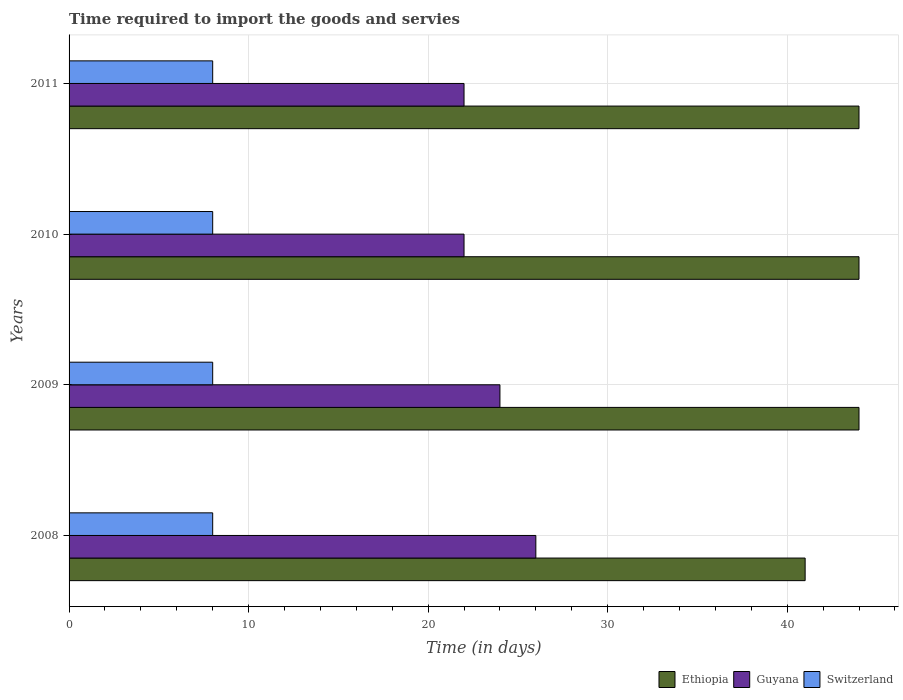Are the number of bars on each tick of the Y-axis equal?
Provide a short and direct response. Yes. How many bars are there on the 4th tick from the top?
Keep it short and to the point. 3. How many bars are there on the 4th tick from the bottom?
Offer a very short reply. 3. What is the label of the 4th group of bars from the top?
Your response must be concise. 2008. In how many cases, is the number of bars for a given year not equal to the number of legend labels?
Offer a terse response. 0. What is the number of days required to import the goods and services in Switzerland in 2011?
Offer a very short reply. 8. Across all years, what is the maximum number of days required to import the goods and services in Guyana?
Provide a succinct answer. 26. Across all years, what is the minimum number of days required to import the goods and services in Switzerland?
Offer a very short reply. 8. In which year was the number of days required to import the goods and services in Ethiopia maximum?
Provide a succinct answer. 2009. What is the total number of days required to import the goods and services in Ethiopia in the graph?
Offer a very short reply. 173. What is the difference between the number of days required to import the goods and services in Ethiopia in 2009 and that in 2010?
Make the answer very short. 0. What is the difference between the number of days required to import the goods and services in Ethiopia in 2011 and the number of days required to import the goods and services in Guyana in 2008?
Provide a succinct answer. 18. What is the average number of days required to import the goods and services in Switzerland per year?
Your answer should be very brief. 8. In the year 2009, what is the difference between the number of days required to import the goods and services in Ethiopia and number of days required to import the goods and services in Guyana?
Provide a short and direct response. 20. What is the ratio of the number of days required to import the goods and services in Ethiopia in 2010 to that in 2011?
Ensure brevity in your answer.  1. Is the number of days required to import the goods and services in Switzerland in 2008 less than that in 2009?
Your answer should be very brief. No. What is the difference between the highest and the second highest number of days required to import the goods and services in Switzerland?
Provide a succinct answer. 0. What is the difference between the highest and the lowest number of days required to import the goods and services in Guyana?
Provide a succinct answer. 4. Is the sum of the number of days required to import the goods and services in Switzerland in 2009 and 2011 greater than the maximum number of days required to import the goods and services in Ethiopia across all years?
Offer a terse response. No. What does the 3rd bar from the top in 2010 represents?
Provide a short and direct response. Ethiopia. What does the 2nd bar from the bottom in 2010 represents?
Your answer should be very brief. Guyana. Is it the case that in every year, the sum of the number of days required to import the goods and services in Guyana and number of days required to import the goods and services in Switzerland is greater than the number of days required to import the goods and services in Ethiopia?
Offer a terse response. No. Where does the legend appear in the graph?
Make the answer very short. Bottom right. What is the title of the graph?
Your response must be concise. Time required to import the goods and servies. Does "Macao" appear as one of the legend labels in the graph?
Ensure brevity in your answer.  No. What is the label or title of the X-axis?
Your response must be concise. Time (in days). What is the Time (in days) in Ethiopia in 2008?
Keep it short and to the point. 41. What is the Time (in days) in Guyana in 2008?
Make the answer very short. 26. What is the Time (in days) in Switzerland in 2008?
Make the answer very short. 8. What is the Time (in days) of Ethiopia in 2009?
Your answer should be compact. 44. What is the Time (in days) of Switzerland in 2010?
Offer a terse response. 8. What is the Time (in days) of Ethiopia in 2011?
Your answer should be compact. 44. Across all years, what is the maximum Time (in days) in Ethiopia?
Provide a short and direct response. 44. Across all years, what is the maximum Time (in days) of Guyana?
Your response must be concise. 26. Across all years, what is the minimum Time (in days) of Switzerland?
Keep it short and to the point. 8. What is the total Time (in days) in Ethiopia in the graph?
Make the answer very short. 173. What is the total Time (in days) in Guyana in the graph?
Offer a terse response. 94. What is the difference between the Time (in days) in Ethiopia in 2008 and that in 2009?
Make the answer very short. -3. What is the difference between the Time (in days) in Guyana in 2008 and that in 2009?
Keep it short and to the point. 2. What is the difference between the Time (in days) in Ethiopia in 2008 and that in 2010?
Your answer should be very brief. -3. What is the difference between the Time (in days) of Guyana in 2008 and that in 2010?
Your answer should be compact. 4. What is the difference between the Time (in days) in Switzerland in 2008 and that in 2010?
Provide a short and direct response. 0. What is the difference between the Time (in days) of Switzerland in 2008 and that in 2011?
Ensure brevity in your answer.  0. What is the difference between the Time (in days) in Guyana in 2009 and that in 2010?
Your answer should be very brief. 2. What is the difference between the Time (in days) of Ethiopia in 2009 and that in 2011?
Offer a terse response. 0. What is the difference between the Time (in days) in Guyana in 2010 and that in 2011?
Give a very brief answer. 0. What is the difference between the Time (in days) in Ethiopia in 2008 and the Time (in days) in Switzerland in 2009?
Your answer should be very brief. 33. What is the difference between the Time (in days) of Guyana in 2008 and the Time (in days) of Switzerland in 2009?
Offer a terse response. 18. What is the difference between the Time (in days) in Ethiopia in 2008 and the Time (in days) in Guyana in 2010?
Give a very brief answer. 19. What is the difference between the Time (in days) of Guyana in 2008 and the Time (in days) of Switzerland in 2010?
Make the answer very short. 18. What is the difference between the Time (in days) in Guyana in 2008 and the Time (in days) in Switzerland in 2011?
Ensure brevity in your answer.  18. What is the difference between the Time (in days) of Guyana in 2009 and the Time (in days) of Switzerland in 2011?
Offer a very short reply. 16. What is the difference between the Time (in days) of Ethiopia in 2010 and the Time (in days) of Guyana in 2011?
Your response must be concise. 22. What is the difference between the Time (in days) in Ethiopia in 2010 and the Time (in days) in Switzerland in 2011?
Provide a succinct answer. 36. What is the average Time (in days) of Ethiopia per year?
Ensure brevity in your answer.  43.25. What is the average Time (in days) of Guyana per year?
Your response must be concise. 23.5. What is the average Time (in days) in Switzerland per year?
Your answer should be very brief. 8. In the year 2008, what is the difference between the Time (in days) of Ethiopia and Time (in days) of Guyana?
Provide a succinct answer. 15. In the year 2008, what is the difference between the Time (in days) of Guyana and Time (in days) of Switzerland?
Give a very brief answer. 18. In the year 2009, what is the difference between the Time (in days) in Ethiopia and Time (in days) in Guyana?
Keep it short and to the point. 20. In the year 2009, what is the difference between the Time (in days) of Ethiopia and Time (in days) of Switzerland?
Ensure brevity in your answer.  36. In the year 2010, what is the difference between the Time (in days) of Guyana and Time (in days) of Switzerland?
Your answer should be compact. 14. In the year 2011, what is the difference between the Time (in days) in Ethiopia and Time (in days) in Guyana?
Your response must be concise. 22. In the year 2011, what is the difference between the Time (in days) of Guyana and Time (in days) of Switzerland?
Your response must be concise. 14. What is the ratio of the Time (in days) in Ethiopia in 2008 to that in 2009?
Make the answer very short. 0.93. What is the ratio of the Time (in days) of Ethiopia in 2008 to that in 2010?
Offer a terse response. 0.93. What is the ratio of the Time (in days) in Guyana in 2008 to that in 2010?
Your response must be concise. 1.18. What is the ratio of the Time (in days) in Switzerland in 2008 to that in 2010?
Your answer should be compact. 1. What is the ratio of the Time (in days) of Ethiopia in 2008 to that in 2011?
Ensure brevity in your answer.  0.93. What is the ratio of the Time (in days) of Guyana in 2008 to that in 2011?
Give a very brief answer. 1.18. What is the ratio of the Time (in days) in Switzerland in 2008 to that in 2011?
Offer a terse response. 1. What is the ratio of the Time (in days) in Ethiopia in 2009 to that in 2011?
Provide a short and direct response. 1. What is the ratio of the Time (in days) of Switzerland in 2009 to that in 2011?
Keep it short and to the point. 1. What is the ratio of the Time (in days) in Guyana in 2010 to that in 2011?
Ensure brevity in your answer.  1. What is the difference between the highest and the second highest Time (in days) in Ethiopia?
Ensure brevity in your answer.  0. What is the difference between the highest and the second highest Time (in days) in Guyana?
Your answer should be very brief. 2. What is the difference between the highest and the second highest Time (in days) in Switzerland?
Provide a short and direct response. 0. What is the difference between the highest and the lowest Time (in days) of Guyana?
Keep it short and to the point. 4. What is the difference between the highest and the lowest Time (in days) of Switzerland?
Keep it short and to the point. 0. 